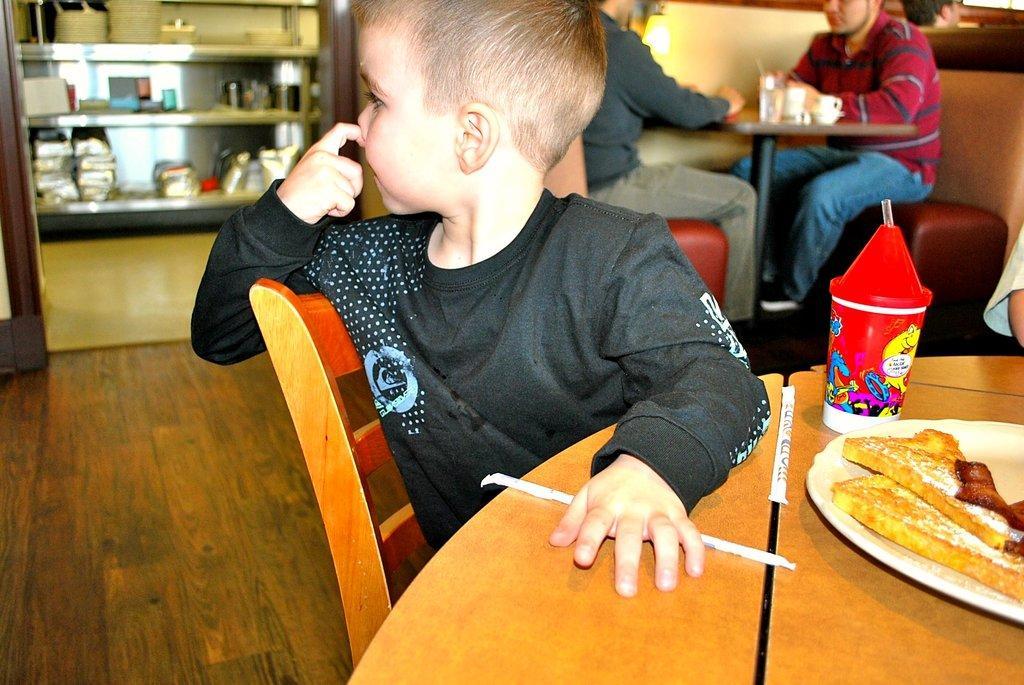Can you describe this image briefly? In this picture a kid is sitting on the table with food eatables on top of it. In the background we also observe people sitting on the tables and there is a metal shelf filled with objects. 